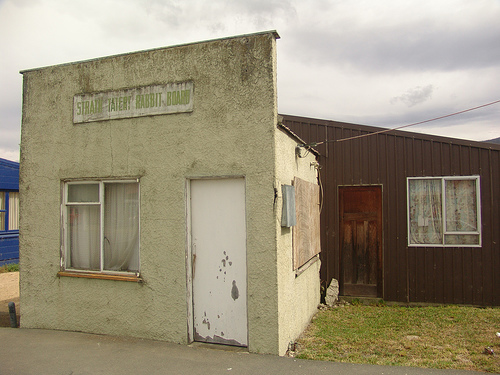<image>
Is there a window above the grass? No. The window is not positioned above the grass. The vertical arrangement shows a different relationship. 